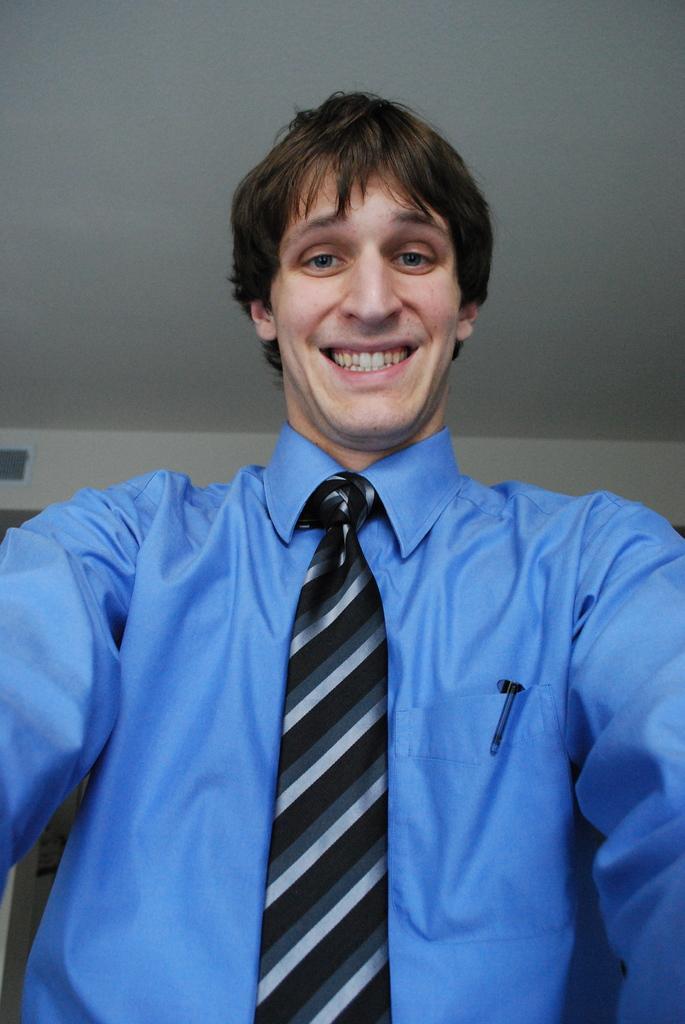Can you describe this image briefly? There is one person standing in the middle of this image and wearing a blue color shirt ,and there is a wall in the background. 